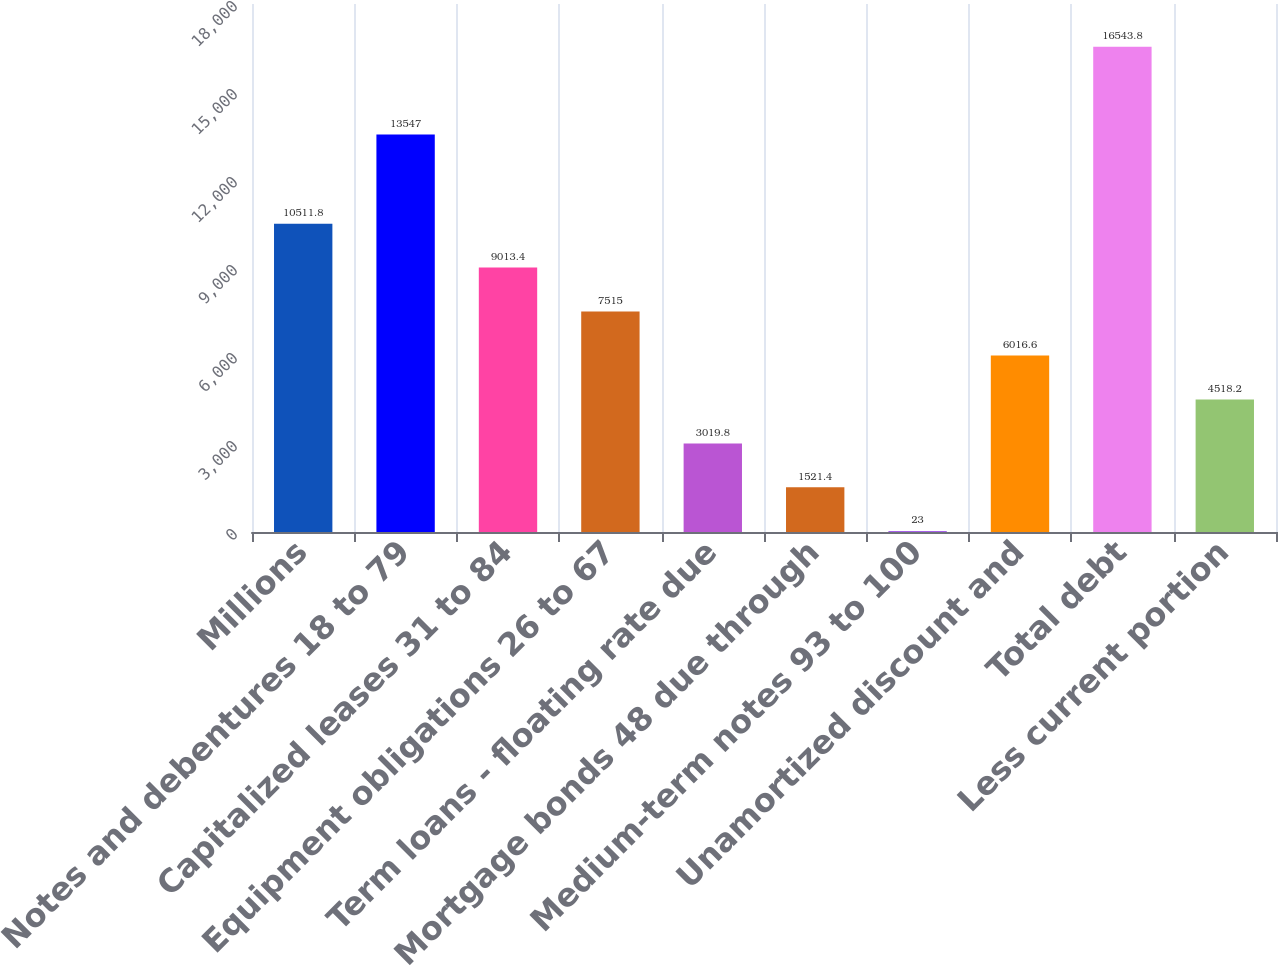<chart> <loc_0><loc_0><loc_500><loc_500><bar_chart><fcel>Millions<fcel>Notes and debentures 18 to 79<fcel>Capitalized leases 31 to 84<fcel>Equipment obligations 26 to 67<fcel>Term loans - floating rate due<fcel>Mortgage bonds 48 due through<fcel>Medium-term notes 93 to 100<fcel>Unamortized discount and<fcel>Total debt<fcel>Less current portion<nl><fcel>10511.8<fcel>13547<fcel>9013.4<fcel>7515<fcel>3019.8<fcel>1521.4<fcel>23<fcel>6016.6<fcel>16543.8<fcel>4518.2<nl></chart> 